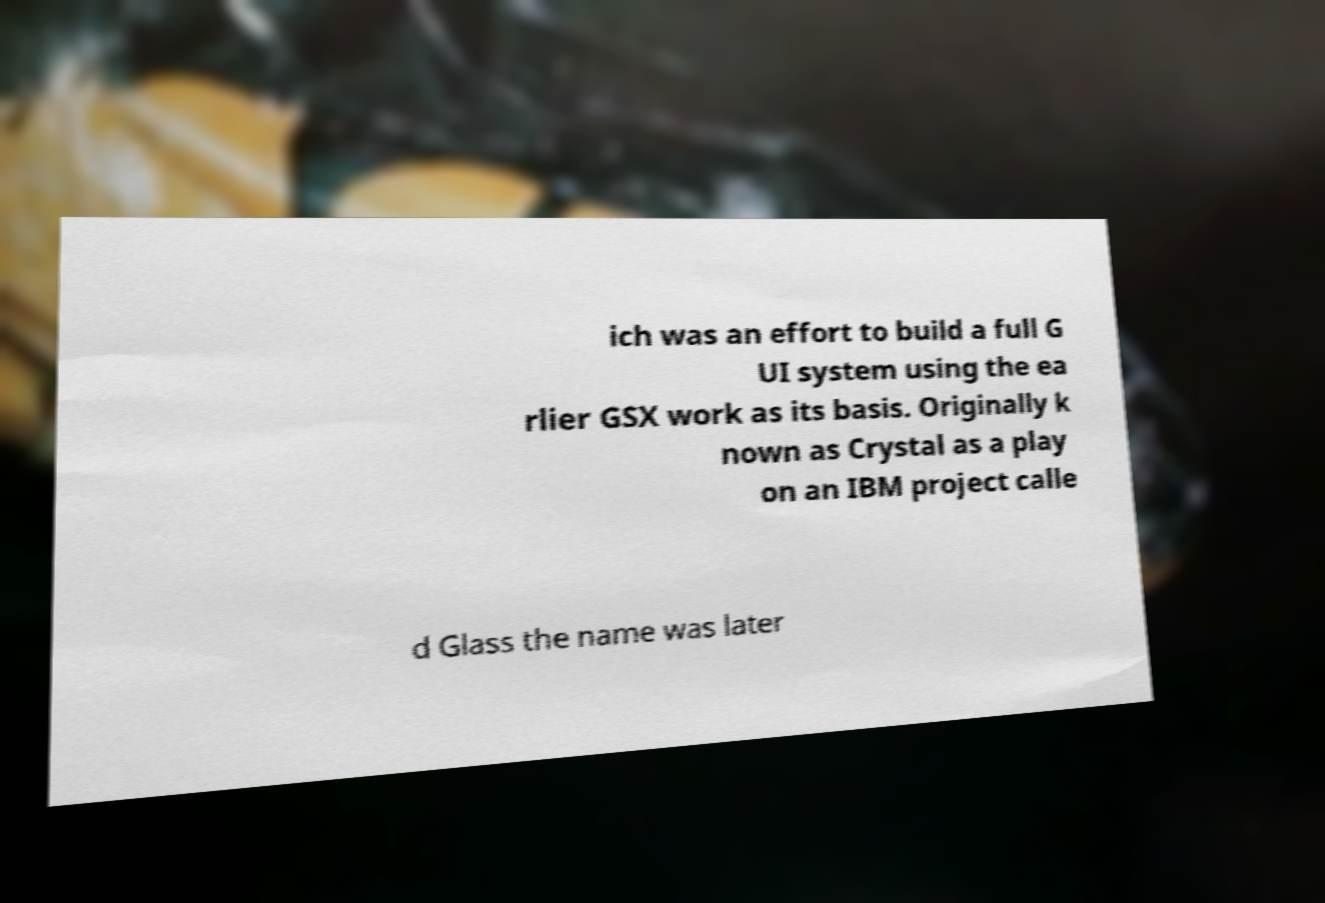Could you extract and type out the text from this image? ich was an effort to build a full G UI system using the ea rlier GSX work as its basis. Originally k nown as Crystal as a play on an IBM project calle d Glass the name was later 